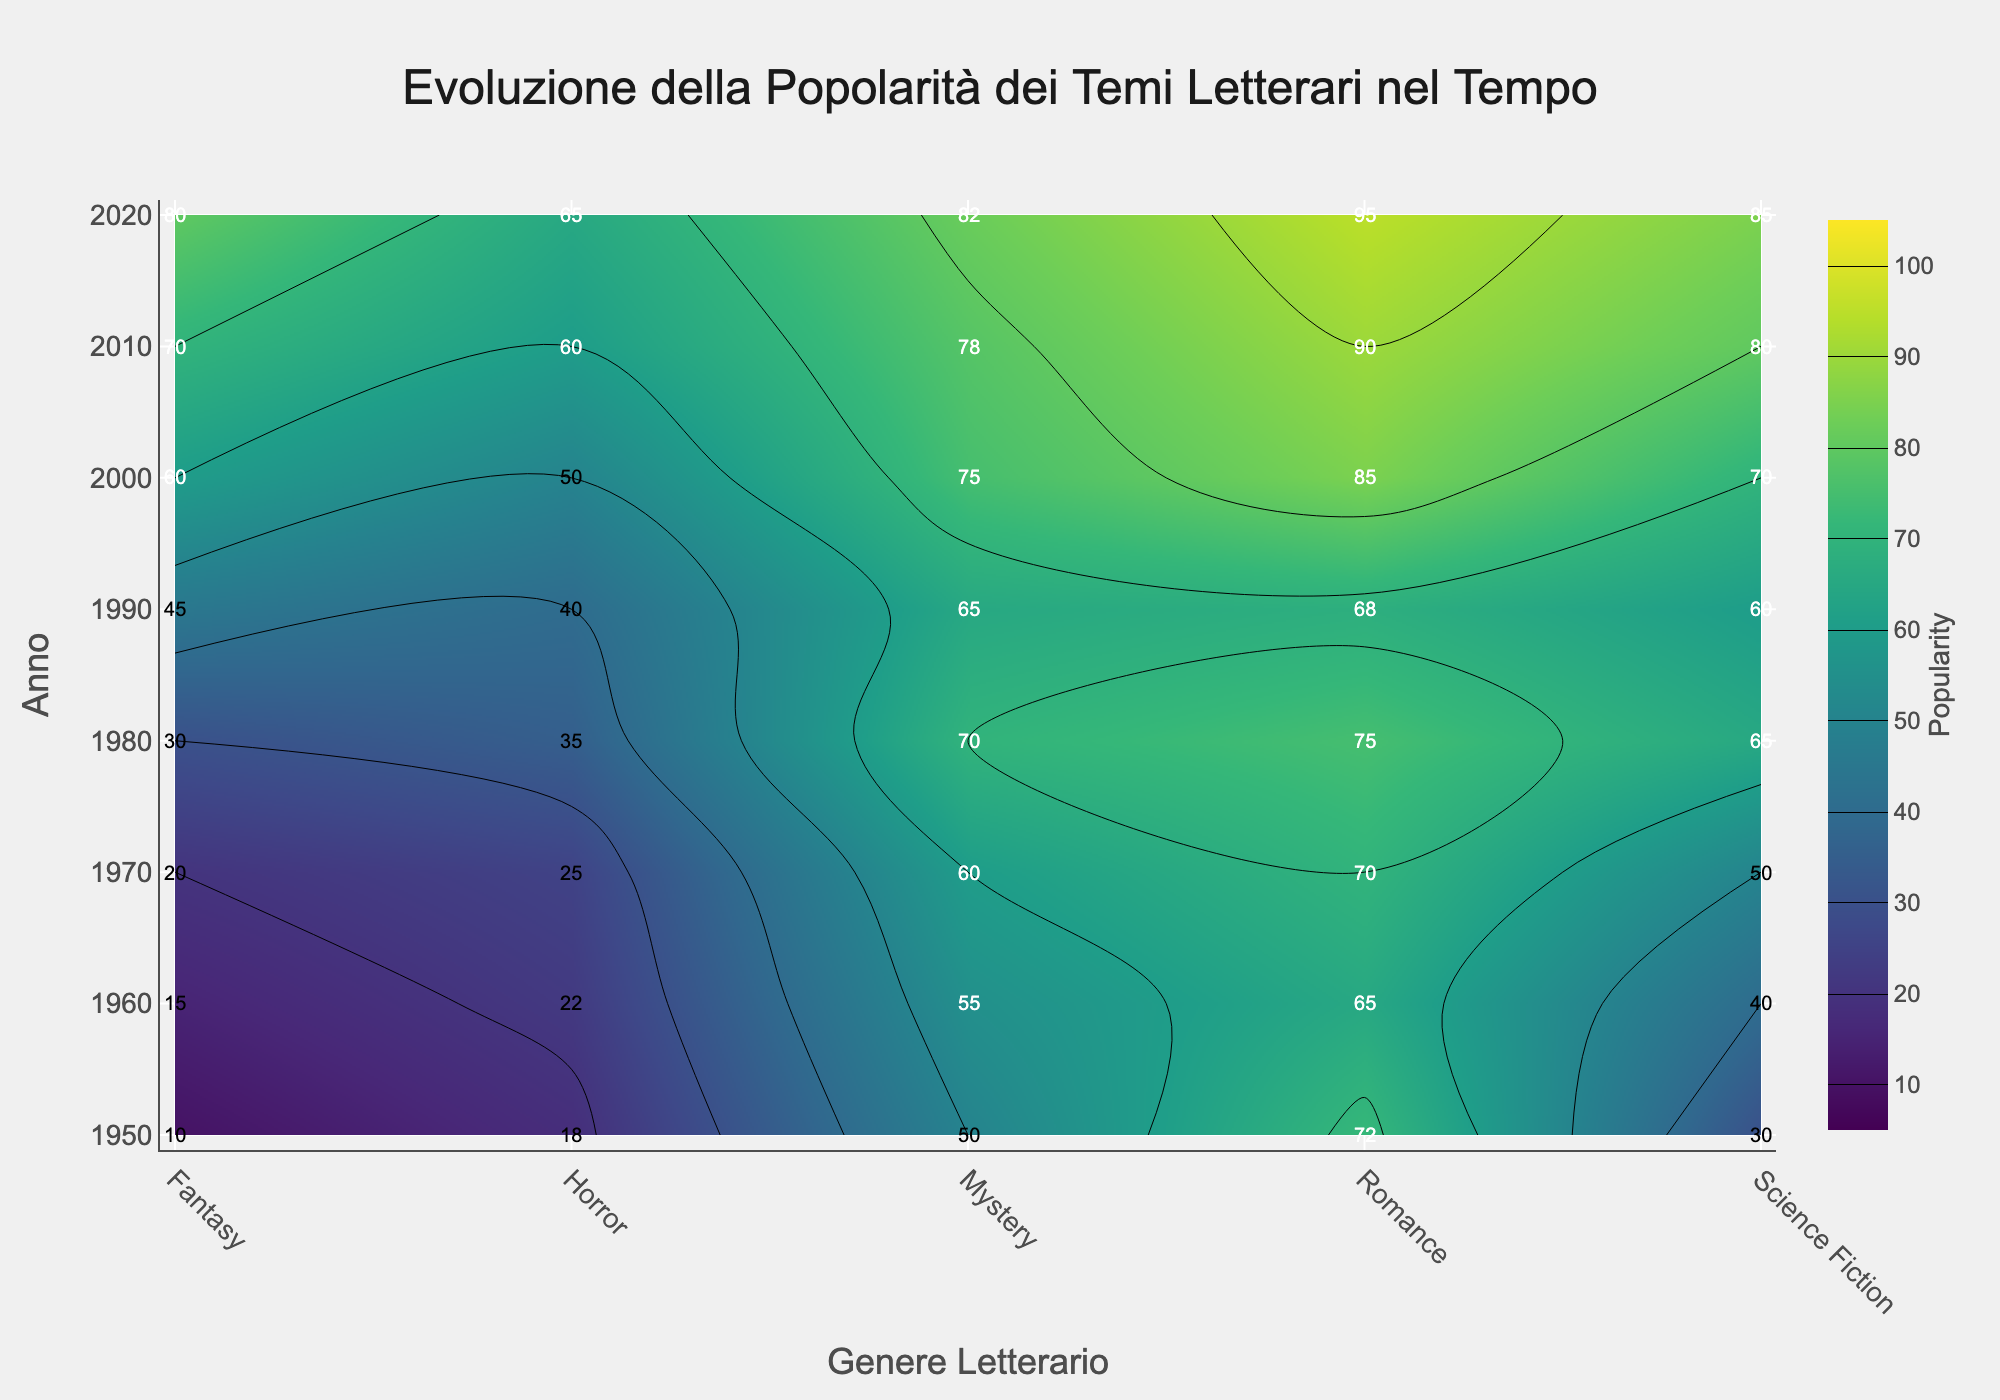What is the title of the figure? The title of the figure is located at the top, in a large font size and central position.
Answer: Evoluzione della Popolarità dei Temi Letterari nel Tempo What are the genres depicted on the x-axis? The x-axis, labeled "Genere Letterario," displays the different writing themes plotted horizontally.
Answer: Romance, Science Fiction, Fantasy, Horror, Mystery Which year had the highest popularity for Horror, and what was the value? Look at the contour plot and find the highest peak for Horror along the vertical axis; read the corresponding year and value annotated in the plot.
Answer: 2020, 65 What is the range of years shown on the y-axis? The y-axis lists the years, which can be identified from the minimum to maximum values displayed vertically.
Answer: 1950 to 2020 Which genre showed the most significant increase in popularity from 1950 to 2020? Compare the popularity values of each genre from 1950 and 2020; identify which genre has the largest difference.
Answer: Fantasy How does the popularity of Romance compare between 1970 and 2000? Locate the popularity values of Romance for 1970 and 2000, then compare these values numerically.
Answer: 70 in 1970, 85 in 2000; increased Which decade saw the largest jump in popularity for Science Fiction? Determine the popularity values for Science Fiction for each decade, calculate the differences, and identify the largest increase.
Answer: 1970s to 1980s What color represents a popularity value of 80 according to the color scale? Check the color scale legend for the color that corresponds to a popularity value of 80.
Answer: Light green Which theme remained consistently popular across all years? Evaluate the contour plot for themes that maintain high popularity levels throughout all years, with lesser fluctuation.
Answer: Romance 